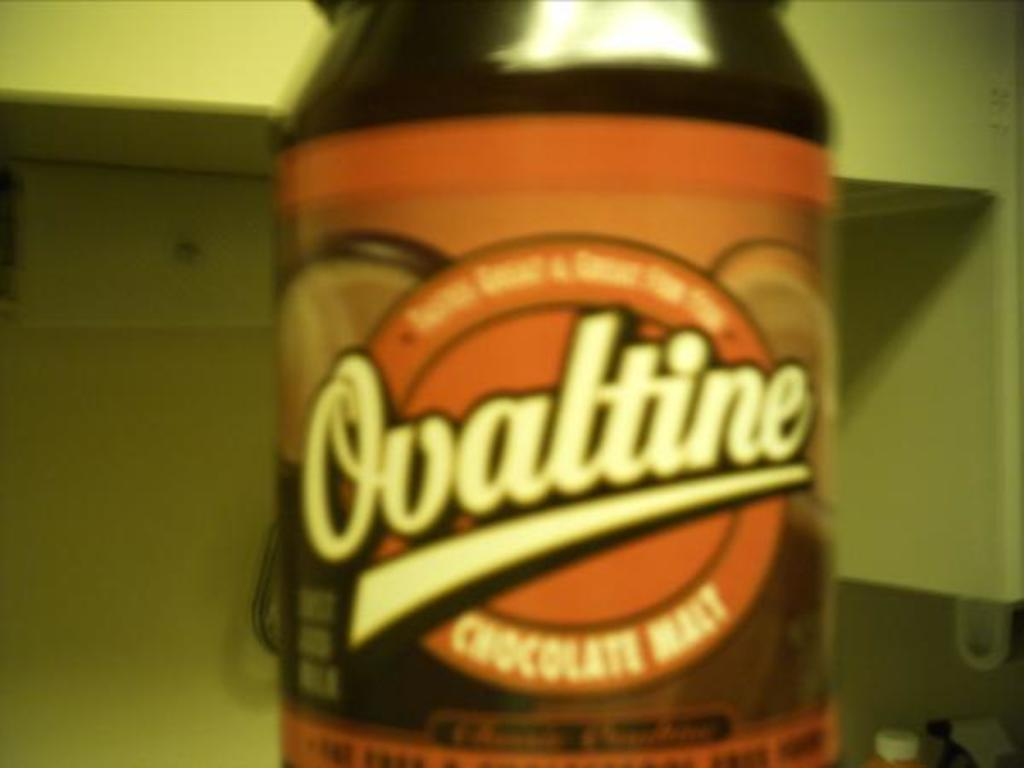<image>
Summarize the visual content of the image. A blurry and closeup shot of bottle of Ovaltine chocolate malt 